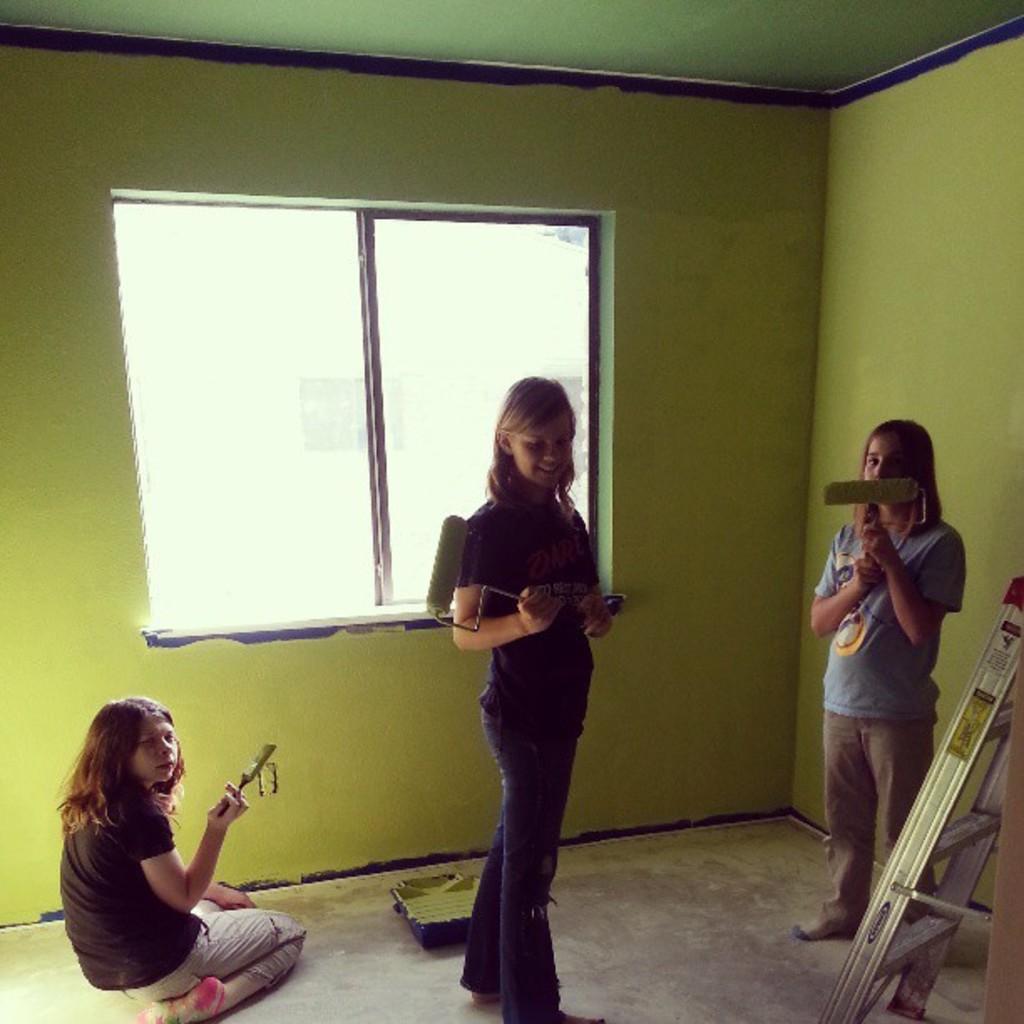In one or two sentences, can you explain what this image depicts? The image is taken inside a room. In this picture we can see a group of girls painting the wall. On the right there is a ladder. In the center it is window. At the top it is ceiling. 